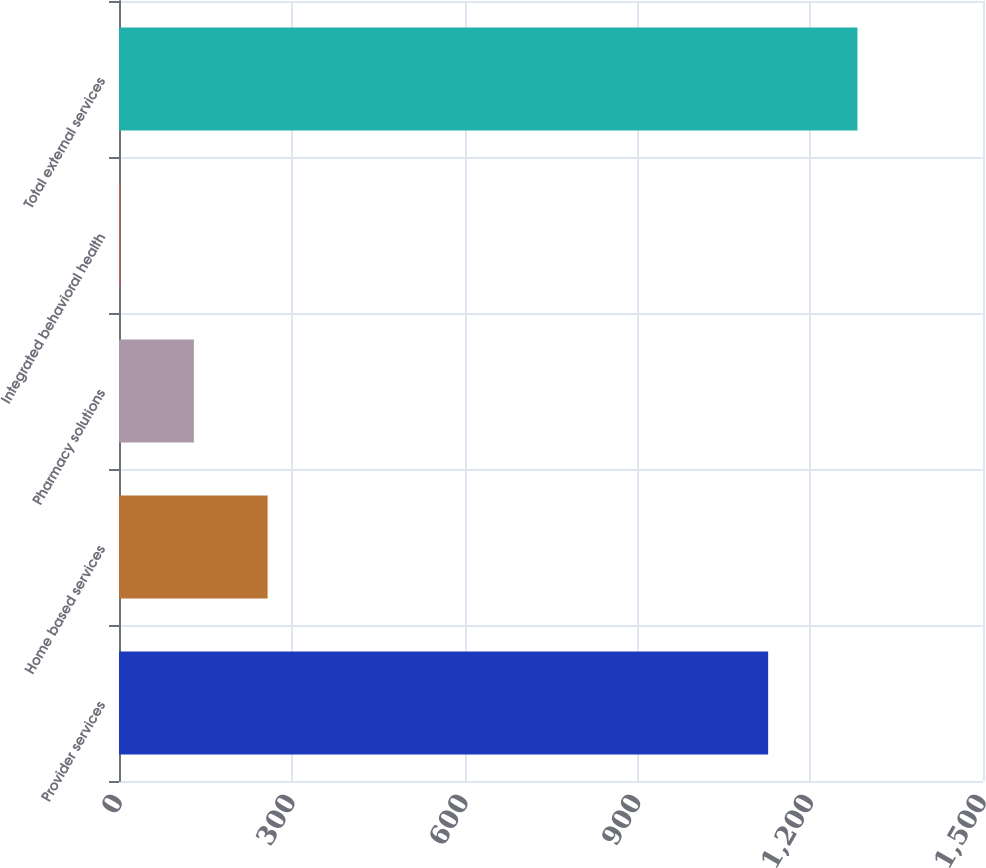Convert chart to OTSL. <chart><loc_0><loc_0><loc_500><loc_500><bar_chart><fcel>Provider services<fcel>Home based services<fcel>Pharmacy solutions<fcel>Integrated behavioral health<fcel>Total external services<nl><fcel>1127<fcel>258<fcel>130<fcel>2<fcel>1282<nl></chart> 